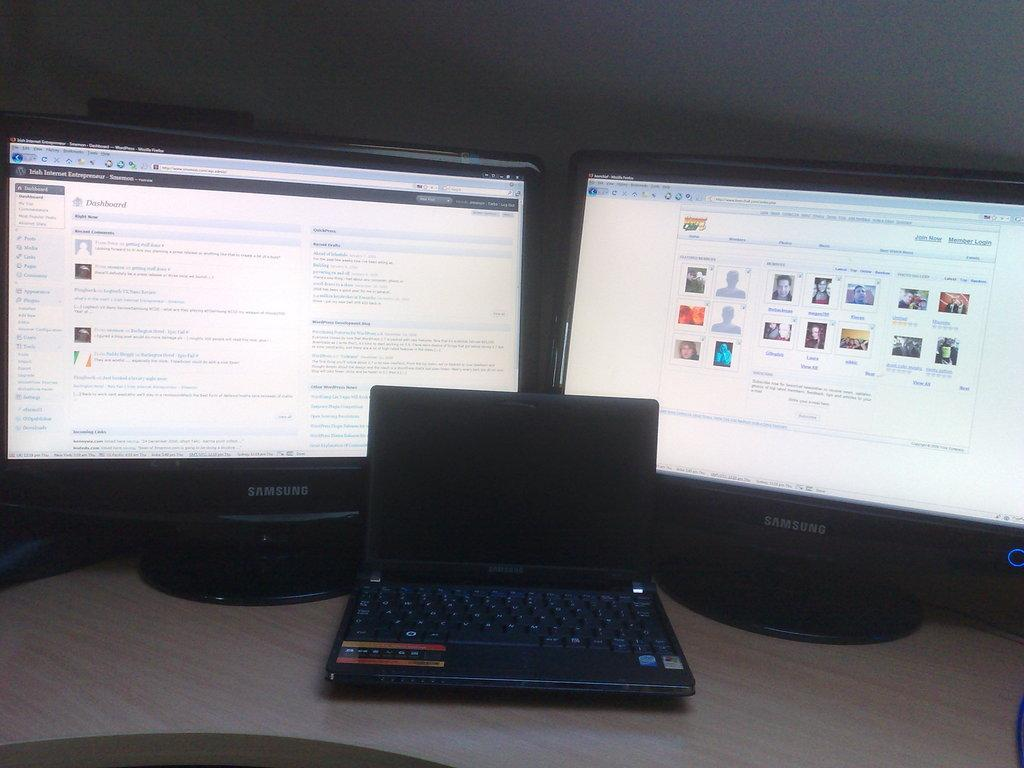<image>
Give a short and clear explanation of the subsequent image. a laptop computer in front of two monitors, one of which has the word dashboard at the top left 